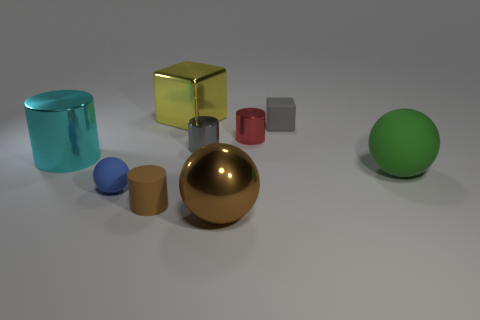Subtract 2 cylinders. How many cylinders are left? 2 Subtract all gray cubes. How many cubes are left? 1 Subtract all small red metal cylinders. How many cylinders are left? 3 Subtract all cubes. How many objects are left? 7 Subtract 1 green balls. How many objects are left? 8 Subtract all yellow blocks. Subtract all yellow cylinders. How many blocks are left? 1 Subtract all green cylinders. How many purple spheres are left? 0 Subtract all tiny blue metal blocks. Subtract all tiny things. How many objects are left? 4 Add 4 small red metal cylinders. How many small red metal cylinders are left? 5 Add 7 brown things. How many brown things exist? 9 